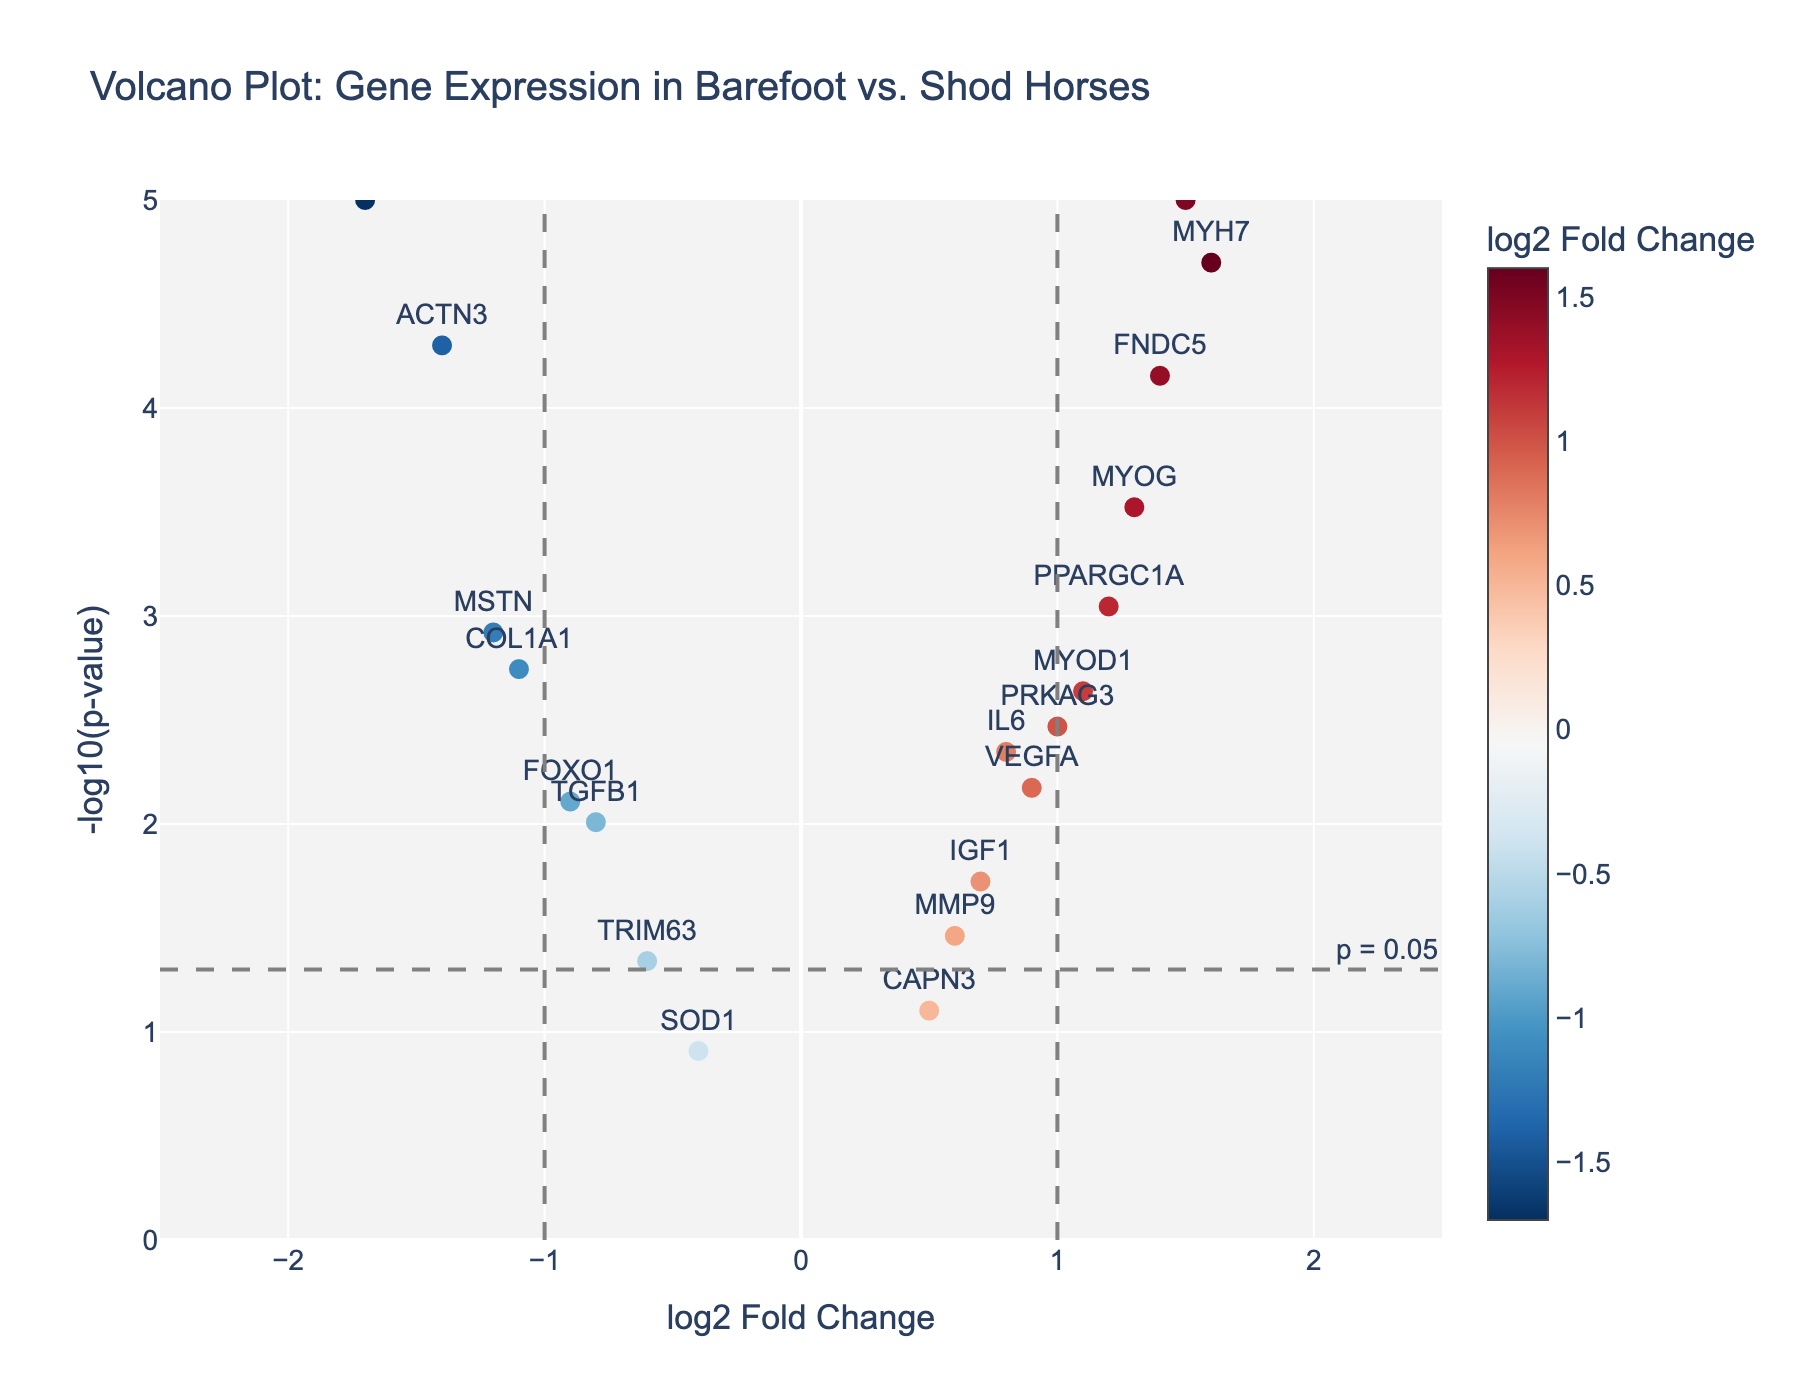Which gene has the highest log2FoldChange in barefoot vs. shod horses? Locate the gene with the highest X-axis value (log2FoldChange). The highest log2FoldChange is for MYH7 with a value of 1.6.
Answer: MYH7 How many genes have a log2FoldChange greater than 1? Count the number of data points with log2FoldChange values above the threshold of 1 on the X-axis. There are 4 such genes: MYOD1, MYOG, PPARGC1A, and MYH7.
Answer: 4 What is the p-value threshold shown on the plot? Find the horizontal line drawn on the plot to indicate the p-value threshold. The annotation text next to this line shows "p = 0.05."
Answer: 0.05 Which gene has the most significant p-value? Identify the gene with the highest Y-axis value (-log10(p-value)). The highest significance (lowest p-value) is indicated by MSTN with a -log10(p-value) of 5.
Answer: MSTN Which genes are upregulated (log2FoldChange > 0) and have significant p-values (p-value < 0.05)? Look for the genes located above the horizontal line (indicating significant p-values) and to the right of the vertical line at log2FoldChange = 0. These genes are IL6, PPAR_alpha, MYOD1, MYOG, PPARGC1A, VEGFA, PRKAG3, FNDC5, and MYH7.
Answer: 9 genes How many genes have a log2FoldChange less than -1 and p-value below 0.05? Count the data points that are to the left of the vertical line at -1 and above the horizontal line indicating p-value < 0.05. There are two genes, MSTN and COL1A1.
Answer: 2 Which gene has the lowest log2FoldChange in barefoot horses compared to shod horses? Identify the gene with the smallest X-axis value (log2FoldChange). The lowest log2FoldChange is for MSTN with a value of -1.7.
Answer: MSTN Are there any genes with a log2FoldChange of exactly zero? Check if any dots align directly with the vertical line at 0 on the X-axis. No gene is positioned exactly on the vertical line at log2FoldChange = 0.
Answer: No What is the -log10(p-value) of the gene with log2FoldChange closest to 1.0? Locate the gene closest to 1.0 on the X-axis (PRKAG3) and read the corresponding Y-axis value. PRKAG3 has a -log10(p-value) around 2.467.
Answer: Around 2.467 How many genes have a p-value greater than 0.05? Look at the data points below the horizontal significance line representing p = 0.05. There are four genes: SOD1, CAPN3, TRIM63, and MMP9.
Answer: 4 